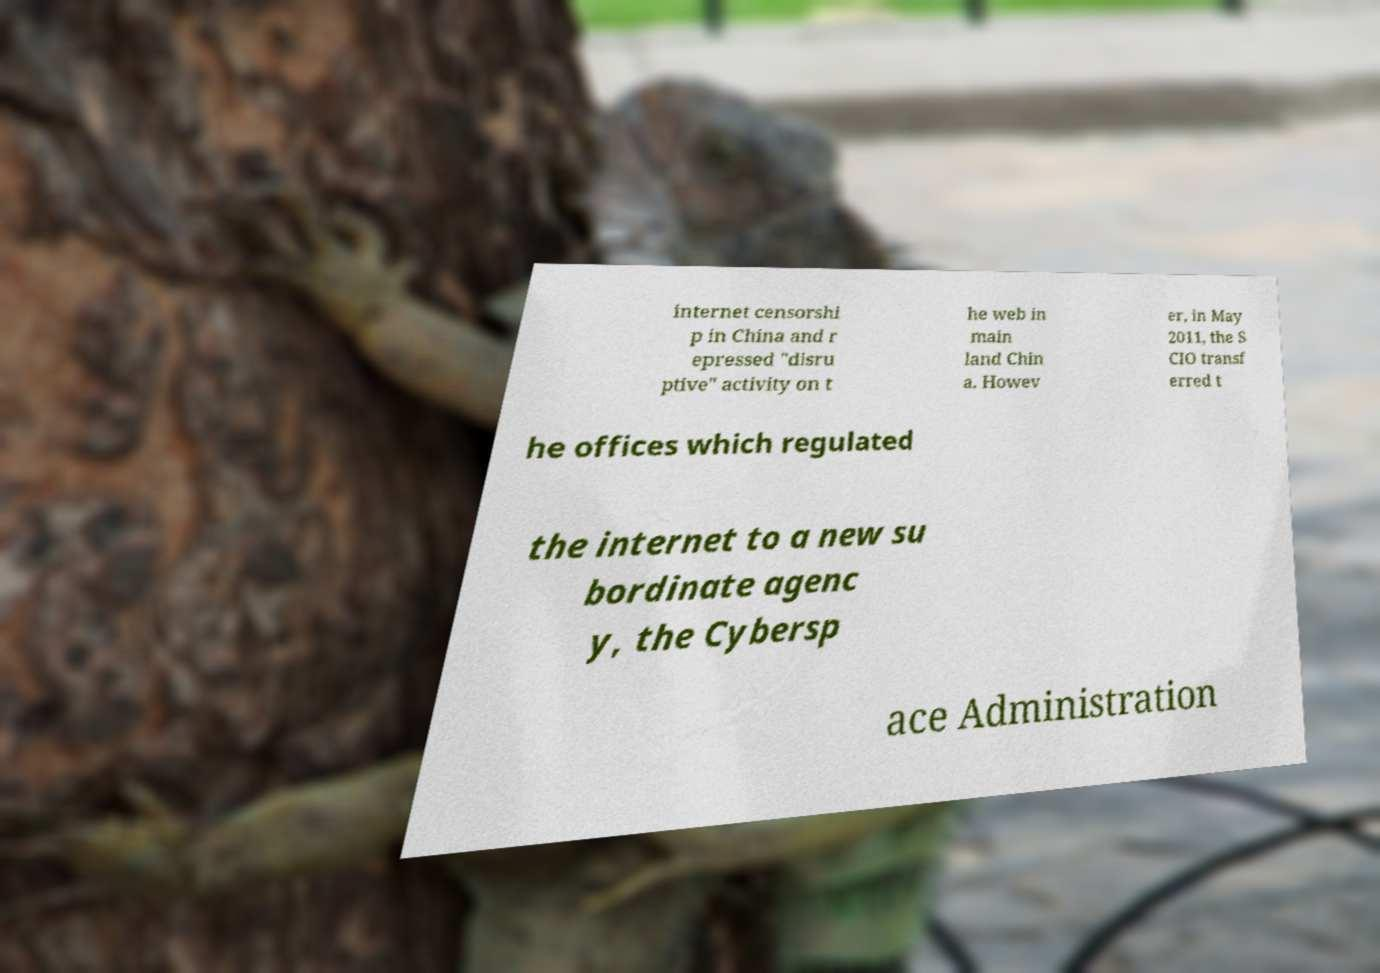For documentation purposes, I need the text within this image transcribed. Could you provide that? internet censorshi p in China and r epressed "disru ptive" activity on t he web in main land Chin a. Howev er, in May 2011, the S CIO transf erred t he offices which regulated the internet to a new su bordinate agenc y, the Cybersp ace Administration 